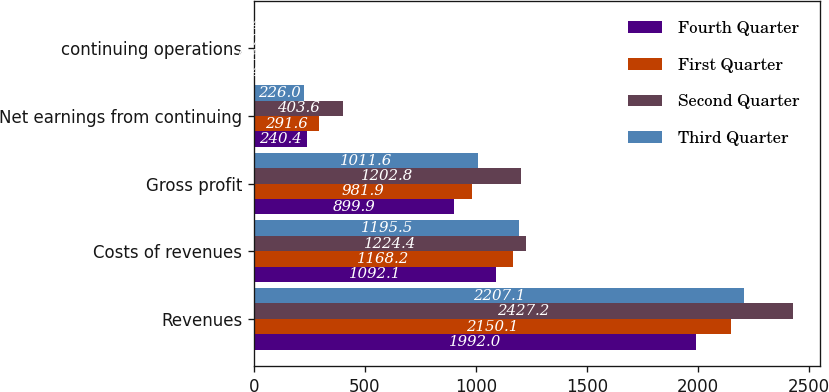Convert chart. <chart><loc_0><loc_0><loc_500><loc_500><stacked_bar_chart><ecel><fcel>Revenues<fcel>Costs of revenues<fcel>Gross profit<fcel>Net earnings from continuing<fcel>continuing operations<nl><fcel>Fourth Quarter<fcel>1992<fcel>1092.1<fcel>899.9<fcel>240.4<fcel>0.45<nl><fcel>First Quarter<fcel>2150.1<fcel>1168.2<fcel>981.9<fcel>291.6<fcel>0.56<nl><fcel>Second Quarter<fcel>2427.2<fcel>1224.4<fcel>1202.8<fcel>403.6<fcel>0.78<nl><fcel>Third Quarter<fcel>2207.1<fcel>1195.5<fcel>1011.6<fcel>226<fcel>0.44<nl></chart> 